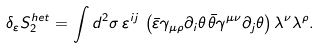<formula> <loc_0><loc_0><loc_500><loc_500>\delta _ { \varepsilon } S _ { 2 } ^ { h e t } = \int d ^ { 2 } \sigma \, \varepsilon ^ { i j } \, \left ( \bar { \varepsilon } \gamma _ { \mu \rho } \partial _ { i } \theta \, \bar { \theta } \gamma ^ { \mu \nu } \partial _ { j } \theta \right ) \lambda ^ { \nu } \lambda ^ { \rho } .</formula> 